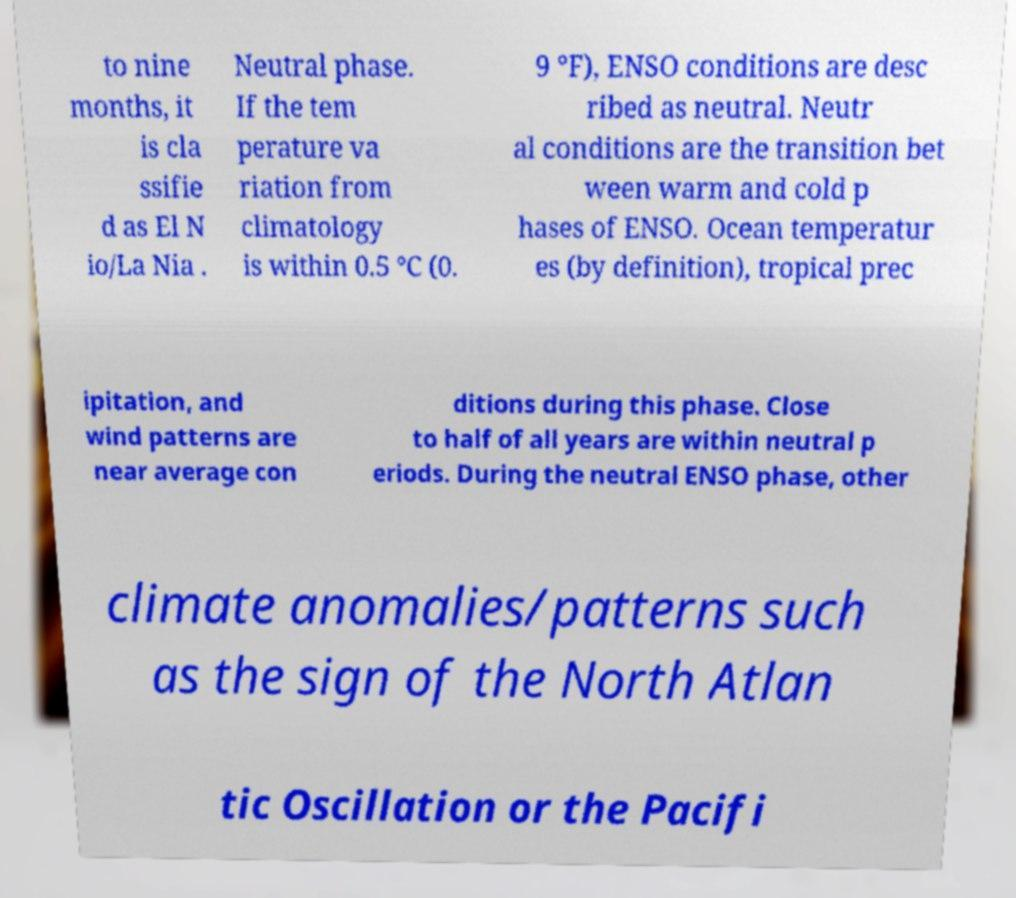Could you assist in decoding the text presented in this image and type it out clearly? to nine months, it is cla ssifie d as El N io/La Nia . Neutral phase. If the tem perature va riation from climatology is within 0.5 °C (0. 9 °F), ENSO conditions are desc ribed as neutral. Neutr al conditions are the transition bet ween warm and cold p hases of ENSO. Ocean temperatur es (by definition), tropical prec ipitation, and wind patterns are near average con ditions during this phase. Close to half of all years are within neutral p eriods. During the neutral ENSO phase, other climate anomalies/patterns such as the sign of the North Atlan tic Oscillation or the Pacifi 